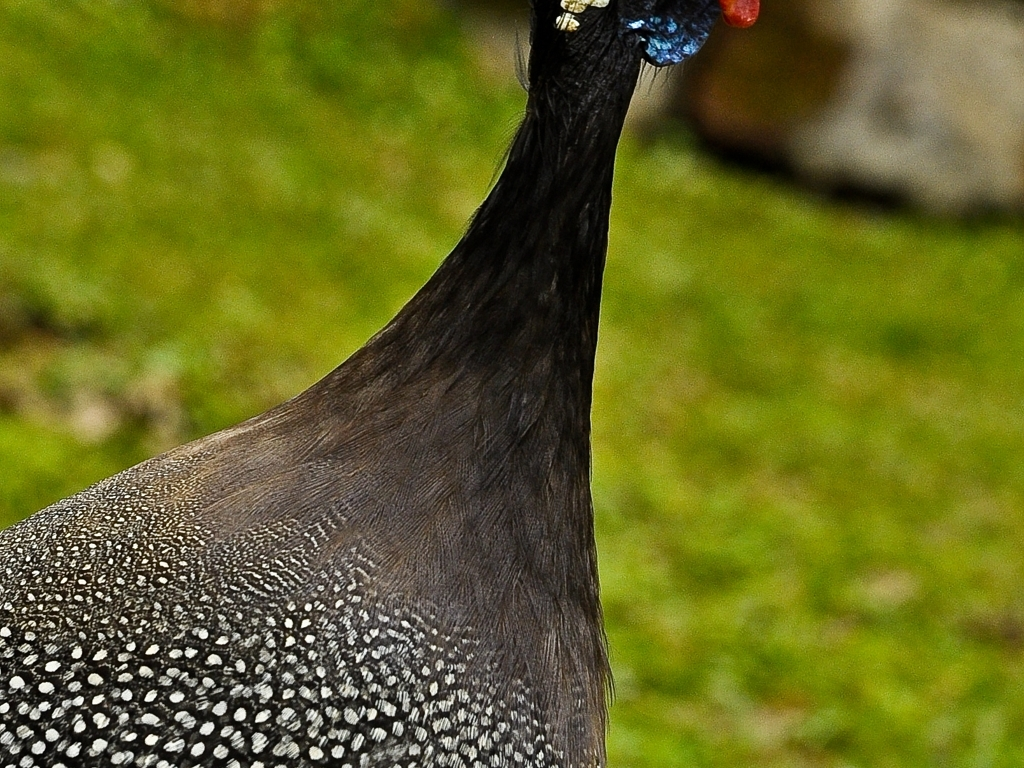Does the main subject of the peacock retain its details and textures? Yes, the main subject of the peacock retains its details and textures. The image clearly shows the intricate patterns of the bird's plumage, with its signature spots appearing well-defined. The fine lines and curves on the feathers, as well as the subtle gradients between the shades, are quite pronounced, exemplifying the peacock's natural beauty and the picture's high resolution. 